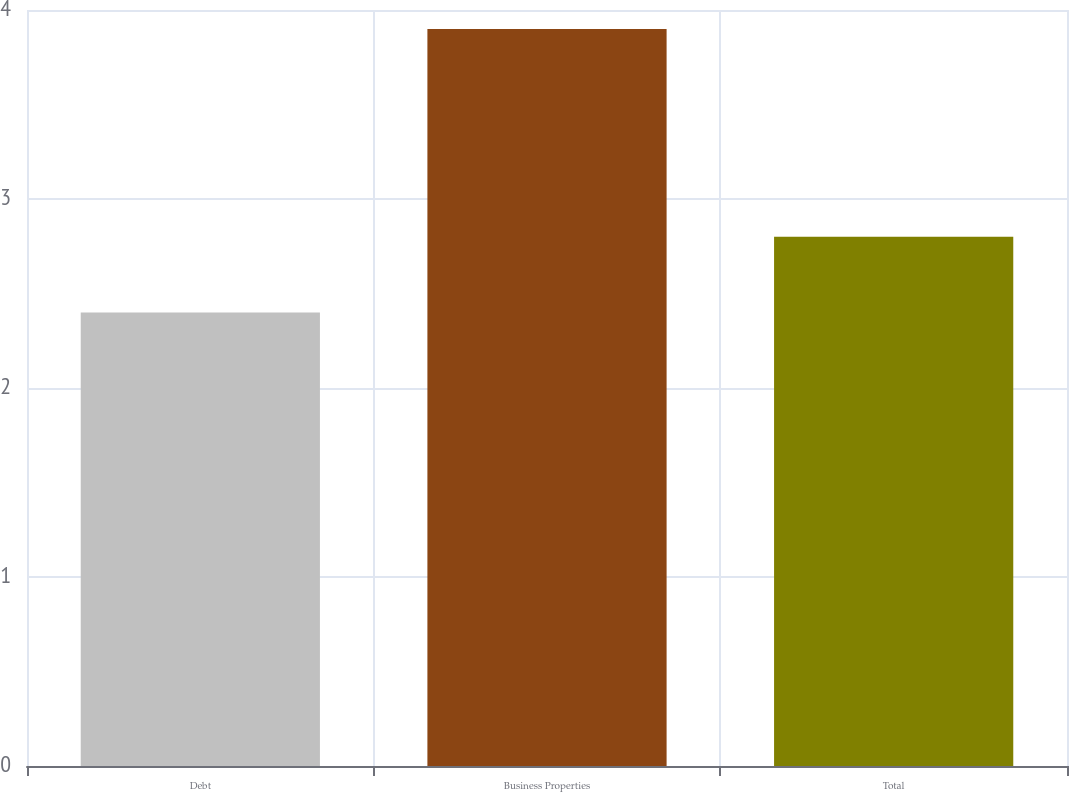Convert chart. <chart><loc_0><loc_0><loc_500><loc_500><bar_chart><fcel>Debt<fcel>Business Properties<fcel>Total<nl><fcel>2.4<fcel>3.9<fcel>2.8<nl></chart> 